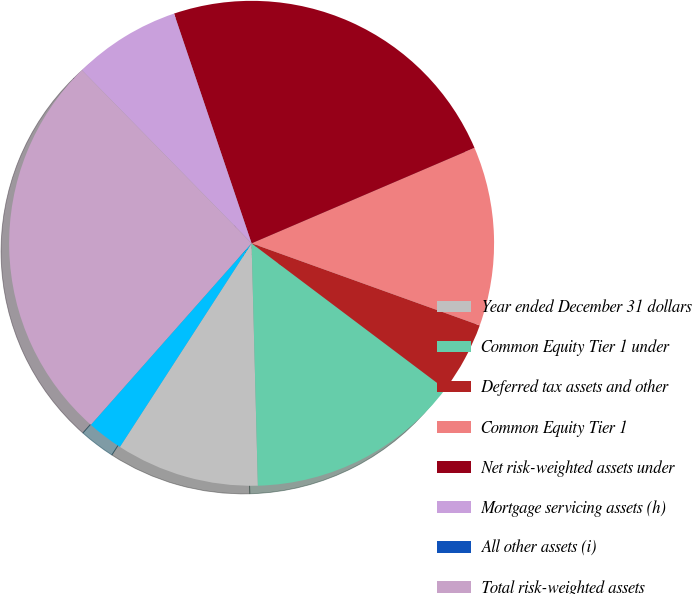<chart> <loc_0><loc_0><loc_500><loc_500><pie_chart><fcel>Year ended December 31 dollars<fcel>Common Equity Tier 1 under<fcel>Deferred tax assets and other<fcel>Common Equity Tier 1<fcel>Net risk-weighted assets under<fcel>Mortgage servicing assets (h)<fcel>All other assets (i)<fcel>Total risk-weighted assets<fcel>Common Equity Tier 1 ratio<nl><fcel>9.55%<fcel>14.32%<fcel>4.77%<fcel>11.94%<fcel>23.74%<fcel>7.16%<fcel>0.0%<fcel>26.13%<fcel>2.39%<nl></chart> 